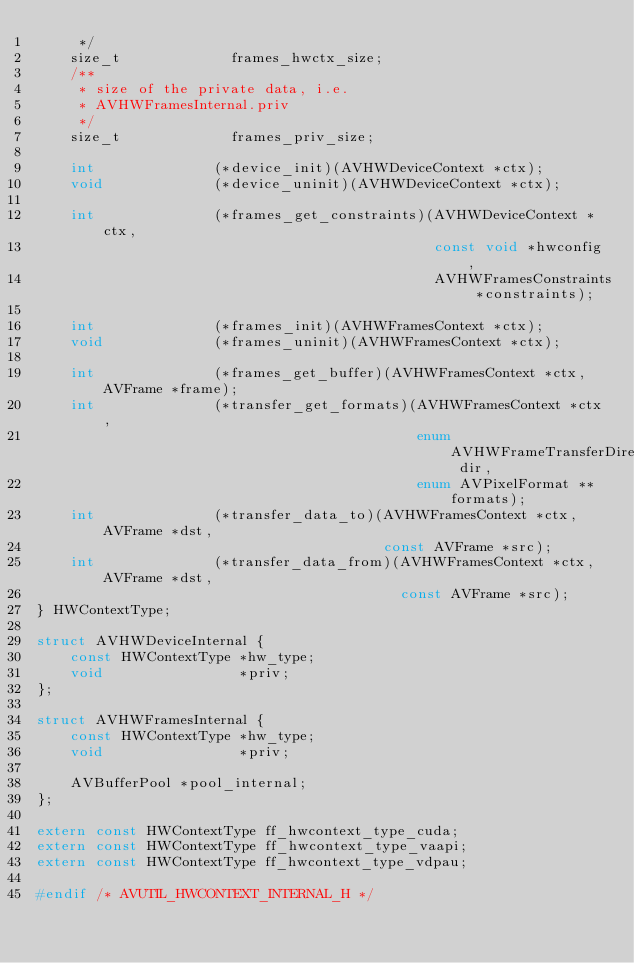<code> <loc_0><loc_0><loc_500><loc_500><_C_>     */
    size_t             frames_hwctx_size;
    /**
     * size of the private data, i.e.
     * AVHWFramesInternal.priv
     */
    size_t             frames_priv_size;

    int              (*device_init)(AVHWDeviceContext *ctx);
    void             (*device_uninit)(AVHWDeviceContext *ctx);

    int              (*frames_get_constraints)(AVHWDeviceContext *ctx,
                                               const void *hwconfig,
                                               AVHWFramesConstraints *constraints);

    int              (*frames_init)(AVHWFramesContext *ctx);
    void             (*frames_uninit)(AVHWFramesContext *ctx);

    int              (*frames_get_buffer)(AVHWFramesContext *ctx, AVFrame *frame);
    int              (*transfer_get_formats)(AVHWFramesContext *ctx,
                                             enum AVHWFrameTransferDirection dir,
                                             enum AVPixelFormat **formats);
    int              (*transfer_data_to)(AVHWFramesContext *ctx, AVFrame *dst,
                                         const AVFrame *src);
    int              (*transfer_data_from)(AVHWFramesContext *ctx, AVFrame *dst,
                                           const AVFrame *src);
} HWContextType;

struct AVHWDeviceInternal {
    const HWContextType *hw_type;
    void                *priv;
};

struct AVHWFramesInternal {
    const HWContextType *hw_type;
    void                *priv;

    AVBufferPool *pool_internal;
};

extern const HWContextType ff_hwcontext_type_cuda;
extern const HWContextType ff_hwcontext_type_vaapi;
extern const HWContextType ff_hwcontext_type_vdpau;

#endif /* AVUTIL_HWCONTEXT_INTERNAL_H */
</code> 